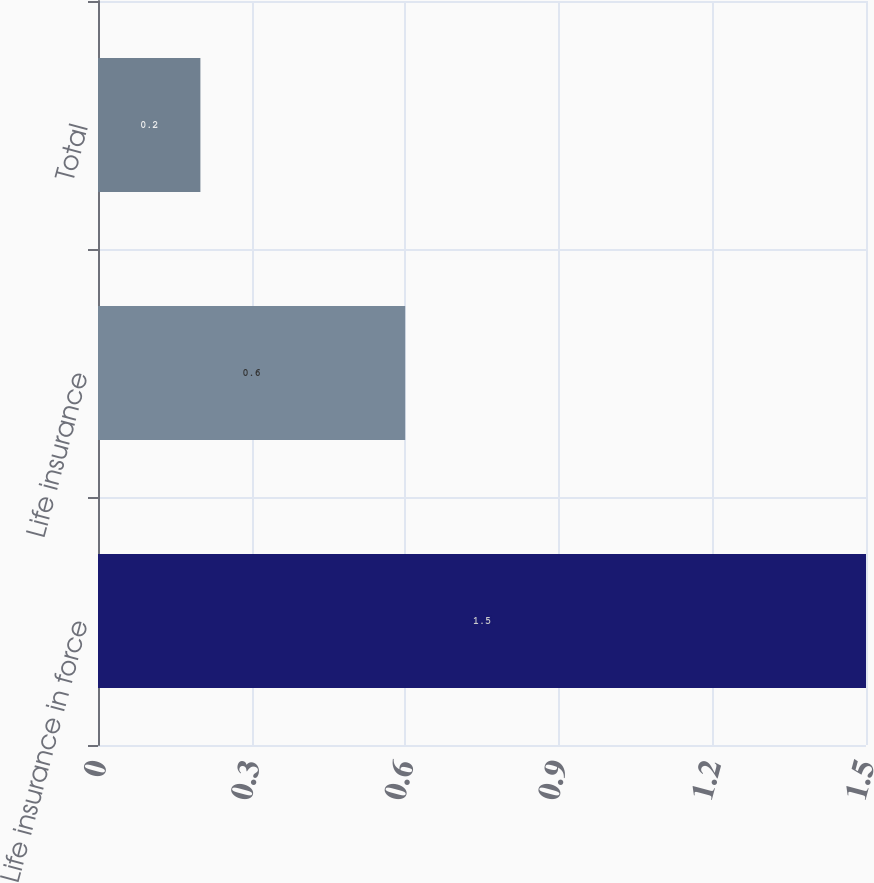Convert chart. <chart><loc_0><loc_0><loc_500><loc_500><bar_chart><fcel>Life insurance in force<fcel>Life insurance<fcel>Total<nl><fcel>1.5<fcel>0.6<fcel>0.2<nl></chart> 